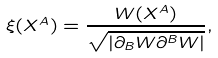Convert formula to latex. <formula><loc_0><loc_0><loc_500><loc_500>\xi ( X ^ { A } ) = \frac { W ( X ^ { A } ) } { \sqrt { | \partial _ { B } W \partial ^ { B } W | } } ,</formula> 